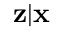<formula> <loc_0><loc_0><loc_500><loc_500>z | x</formula> 